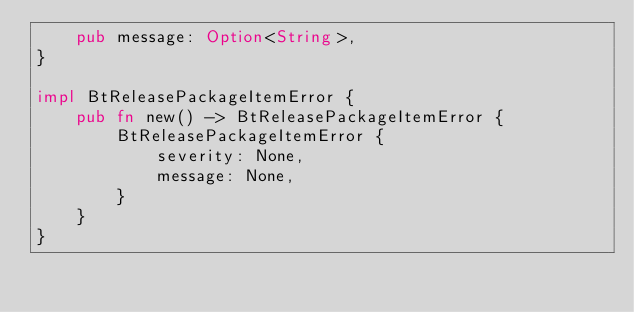Convert code to text. <code><loc_0><loc_0><loc_500><loc_500><_Rust_>    pub message: Option<String>,
}

impl BtReleasePackageItemError {
    pub fn new() -> BtReleasePackageItemError {
        BtReleasePackageItemError {
            severity: None,
            message: None,
        }
    }
}


</code> 